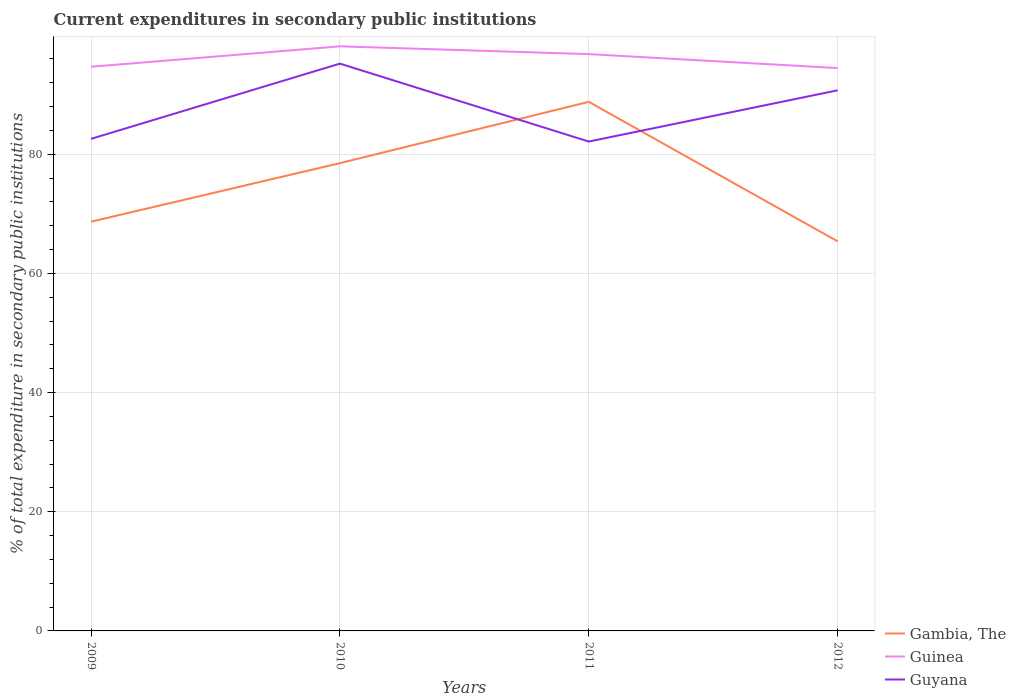How many different coloured lines are there?
Your answer should be very brief. 3. Does the line corresponding to Guyana intersect with the line corresponding to Gambia, The?
Make the answer very short. Yes. Is the number of lines equal to the number of legend labels?
Offer a terse response. Yes. Across all years, what is the maximum current expenditures in secondary public institutions in Guyana?
Ensure brevity in your answer.  82.14. In which year was the current expenditures in secondary public institutions in Guyana maximum?
Offer a terse response. 2011. What is the total current expenditures in secondary public institutions in Guyana in the graph?
Provide a succinct answer. 4.48. What is the difference between the highest and the second highest current expenditures in secondary public institutions in Guinea?
Give a very brief answer. 3.65. Does the graph contain grids?
Your answer should be compact. Yes. How many legend labels are there?
Keep it short and to the point. 3. How are the legend labels stacked?
Give a very brief answer. Vertical. What is the title of the graph?
Ensure brevity in your answer.  Current expenditures in secondary public institutions. Does "Bermuda" appear as one of the legend labels in the graph?
Make the answer very short. No. What is the label or title of the Y-axis?
Your answer should be compact. % of total expenditure in secondary public institutions. What is the % of total expenditure in secondary public institutions in Gambia, The in 2009?
Offer a terse response. 68.69. What is the % of total expenditure in secondary public institutions in Guinea in 2009?
Provide a succinct answer. 94.69. What is the % of total expenditure in secondary public institutions of Guyana in 2009?
Give a very brief answer. 82.59. What is the % of total expenditure in secondary public institutions of Gambia, The in 2010?
Your answer should be compact. 78.52. What is the % of total expenditure in secondary public institutions in Guinea in 2010?
Make the answer very short. 98.12. What is the % of total expenditure in secondary public institutions in Guyana in 2010?
Your answer should be very brief. 95.22. What is the % of total expenditure in secondary public institutions of Gambia, The in 2011?
Provide a short and direct response. 88.81. What is the % of total expenditure in secondary public institutions in Guinea in 2011?
Keep it short and to the point. 96.81. What is the % of total expenditure in secondary public institutions of Guyana in 2011?
Offer a terse response. 82.14. What is the % of total expenditure in secondary public institutions in Gambia, The in 2012?
Your answer should be very brief. 65.39. What is the % of total expenditure in secondary public institutions in Guinea in 2012?
Provide a succinct answer. 94.47. What is the % of total expenditure in secondary public institutions in Guyana in 2012?
Provide a succinct answer. 90.74. Across all years, what is the maximum % of total expenditure in secondary public institutions in Gambia, The?
Give a very brief answer. 88.81. Across all years, what is the maximum % of total expenditure in secondary public institutions in Guinea?
Make the answer very short. 98.12. Across all years, what is the maximum % of total expenditure in secondary public institutions in Guyana?
Give a very brief answer. 95.22. Across all years, what is the minimum % of total expenditure in secondary public institutions of Gambia, The?
Offer a very short reply. 65.39. Across all years, what is the minimum % of total expenditure in secondary public institutions in Guinea?
Keep it short and to the point. 94.47. Across all years, what is the minimum % of total expenditure in secondary public institutions of Guyana?
Your answer should be very brief. 82.14. What is the total % of total expenditure in secondary public institutions of Gambia, The in the graph?
Your response must be concise. 301.4. What is the total % of total expenditure in secondary public institutions in Guinea in the graph?
Your answer should be compact. 384.1. What is the total % of total expenditure in secondary public institutions of Guyana in the graph?
Keep it short and to the point. 350.69. What is the difference between the % of total expenditure in secondary public institutions in Gambia, The in 2009 and that in 2010?
Offer a terse response. -9.83. What is the difference between the % of total expenditure in secondary public institutions of Guinea in 2009 and that in 2010?
Provide a succinct answer. -3.43. What is the difference between the % of total expenditure in secondary public institutions in Guyana in 2009 and that in 2010?
Give a very brief answer. -12.63. What is the difference between the % of total expenditure in secondary public institutions of Gambia, The in 2009 and that in 2011?
Give a very brief answer. -20.12. What is the difference between the % of total expenditure in secondary public institutions in Guinea in 2009 and that in 2011?
Provide a succinct answer. -2.12. What is the difference between the % of total expenditure in secondary public institutions in Guyana in 2009 and that in 2011?
Give a very brief answer. 0.45. What is the difference between the % of total expenditure in secondary public institutions in Gambia, The in 2009 and that in 2012?
Your answer should be very brief. 3.3. What is the difference between the % of total expenditure in secondary public institutions in Guinea in 2009 and that in 2012?
Offer a very short reply. 0.22. What is the difference between the % of total expenditure in secondary public institutions of Guyana in 2009 and that in 2012?
Your answer should be very brief. -8.15. What is the difference between the % of total expenditure in secondary public institutions of Gambia, The in 2010 and that in 2011?
Give a very brief answer. -10.29. What is the difference between the % of total expenditure in secondary public institutions of Guinea in 2010 and that in 2011?
Offer a very short reply. 1.31. What is the difference between the % of total expenditure in secondary public institutions of Guyana in 2010 and that in 2011?
Your answer should be very brief. 13.08. What is the difference between the % of total expenditure in secondary public institutions of Gambia, The in 2010 and that in 2012?
Your answer should be compact. 13.13. What is the difference between the % of total expenditure in secondary public institutions of Guinea in 2010 and that in 2012?
Offer a terse response. 3.65. What is the difference between the % of total expenditure in secondary public institutions in Guyana in 2010 and that in 2012?
Your answer should be compact. 4.48. What is the difference between the % of total expenditure in secondary public institutions of Gambia, The in 2011 and that in 2012?
Your response must be concise. 23.42. What is the difference between the % of total expenditure in secondary public institutions in Guinea in 2011 and that in 2012?
Give a very brief answer. 2.34. What is the difference between the % of total expenditure in secondary public institutions in Guyana in 2011 and that in 2012?
Your response must be concise. -8.6. What is the difference between the % of total expenditure in secondary public institutions in Gambia, The in 2009 and the % of total expenditure in secondary public institutions in Guinea in 2010?
Offer a very short reply. -29.44. What is the difference between the % of total expenditure in secondary public institutions of Gambia, The in 2009 and the % of total expenditure in secondary public institutions of Guyana in 2010?
Your answer should be very brief. -26.53. What is the difference between the % of total expenditure in secondary public institutions of Guinea in 2009 and the % of total expenditure in secondary public institutions of Guyana in 2010?
Offer a very short reply. -0.53. What is the difference between the % of total expenditure in secondary public institutions in Gambia, The in 2009 and the % of total expenditure in secondary public institutions in Guinea in 2011?
Make the answer very short. -28.13. What is the difference between the % of total expenditure in secondary public institutions in Gambia, The in 2009 and the % of total expenditure in secondary public institutions in Guyana in 2011?
Your answer should be very brief. -13.45. What is the difference between the % of total expenditure in secondary public institutions of Guinea in 2009 and the % of total expenditure in secondary public institutions of Guyana in 2011?
Give a very brief answer. 12.55. What is the difference between the % of total expenditure in secondary public institutions in Gambia, The in 2009 and the % of total expenditure in secondary public institutions in Guinea in 2012?
Provide a succinct answer. -25.79. What is the difference between the % of total expenditure in secondary public institutions of Gambia, The in 2009 and the % of total expenditure in secondary public institutions of Guyana in 2012?
Provide a short and direct response. -22.05. What is the difference between the % of total expenditure in secondary public institutions of Guinea in 2009 and the % of total expenditure in secondary public institutions of Guyana in 2012?
Ensure brevity in your answer.  3.95. What is the difference between the % of total expenditure in secondary public institutions in Gambia, The in 2010 and the % of total expenditure in secondary public institutions in Guinea in 2011?
Provide a succinct answer. -18.3. What is the difference between the % of total expenditure in secondary public institutions of Gambia, The in 2010 and the % of total expenditure in secondary public institutions of Guyana in 2011?
Keep it short and to the point. -3.62. What is the difference between the % of total expenditure in secondary public institutions in Guinea in 2010 and the % of total expenditure in secondary public institutions in Guyana in 2011?
Offer a very short reply. 15.98. What is the difference between the % of total expenditure in secondary public institutions in Gambia, The in 2010 and the % of total expenditure in secondary public institutions in Guinea in 2012?
Your answer should be compact. -15.95. What is the difference between the % of total expenditure in secondary public institutions in Gambia, The in 2010 and the % of total expenditure in secondary public institutions in Guyana in 2012?
Ensure brevity in your answer.  -12.22. What is the difference between the % of total expenditure in secondary public institutions of Guinea in 2010 and the % of total expenditure in secondary public institutions of Guyana in 2012?
Ensure brevity in your answer.  7.38. What is the difference between the % of total expenditure in secondary public institutions of Gambia, The in 2011 and the % of total expenditure in secondary public institutions of Guinea in 2012?
Your answer should be very brief. -5.67. What is the difference between the % of total expenditure in secondary public institutions of Gambia, The in 2011 and the % of total expenditure in secondary public institutions of Guyana in 2012?
Your response must be concise. -1.93. What is the difference between the % of total expenditure in secondary public institutions of Guinea in 2011 and the % of total expenditure in secondary public institutions of Guyana in 2012?
Offer a very short reply. 6.07. What is the average % of total expenditure in secondary public institutions in Gambia, The per year?
Your answer should be compact. 75.35. What is the average % of total expenditure in secondary public institutions of Guinea per year?
Make the answer very short. 96.03. What is the average % of total expenditure in secondary public institutions in Guyana per year?
Provide a succinct answer. 87.67. In the year 2009, what is the difference between the % of total expenditure in secondary public institutions of Gambia, The and % of total expenditure in secondary public institutions of Guinea?
Provide a succinct answer. -26.01. In the year 2009, what is the difference between the % of total expenditure in secondary public institutions in Gambia, The and % of total expenditure in secondary public institutions in Guyana?
Give a very brief answer. -13.9. In the year 2009, what is the difference between the % of total expenditure in secondary public institutions of Guinea and % of total expenditure in secondary public institutions of Guyana?
Your response must be concise. 12.1. In the year 2010, what is the difference between the % of total expenditure in secondary public institutions of Gambia, The and % of total expenditure in secondary public institutions of Guinea?
Your response must be concise. -19.6. In the year 2010, what is the difference between the % of total expenditure in secondary public institutions of Gambia, The and % of total expenditure in secondary public institutions of Guyana?
Provide a succinct answer. -16.7. In the year 2010, what is the difference between the % of total expenditure in secondary public institutions of Guinea and % of total expenditure in secondary public institutions of Guyana?
Your answer should be very brief. 2.9. In the year 2011, what is the difference between the % of total expenditure in secondary public institutions of Gambia, The and % of total expenditure in secondary public institutions of Guinea?
Offer a very short reply. -8.01. In the year 2011, what is the difference between the % of total expenditure in secondary public institutions of Gambia, The and % of total expenditure in secondary public institutions of Guyana?
Make the answer very short. 6.67. In the year 2011, what is the difference between the % of total expenditure in secondary public institutions in Guinea and % of total expenditure in secondary public institutions in Guyana?
Offer a terse response. 14.67. In the year 2012, what is the difference between the % of total expenditure in secondary public institutions in Gambia, The and % of total expenditure in secondary public institutions in Guinea?
Offer a terse response. -29.09. In the year 2012, what is the difference between the % of total expenditure in secondary public institutions in Gambia, The and % of total expenditure in secondary public institutions in Guyana?
Your answer should be compact. -25.35. In the year 2012, what is the difference between the % of total expenditure in secondary public institutions in Guinea and % of total expenditure in secondary public institutions in Guyana?
Provide a short and direct response. 3.73. What is the ratio of the % of total expenditure in secondary public institutions in Gambia, The in 2009 to that in 2010?
Provide a succinct answer. 0.87. What is the ratio of the % of total expenditure in secondary public institutions of Guinea in 2009 to that in 2010?
Your answer should be compact. 0.97. What is the ratio of the % of total expenditure in secondary public institutions in Guyana in 2009 to that in 2010?
Provide a short and direct response. 0.87. What is the ratio of the % of total expenditure in secondary public institutions of Gambia, The in 2009 to that in 2011?
Offer a very short reply. 0.77. What is the ratio of the % of total expenditure in secondary public institutions in Guinea in 2009 to that in 2011?
Offer a very short reply. 0.98. What is the ratio of the % of total expenditure in secondary public institutions of Guyana in 2009 to that in 2011?
Your response must be concise. 1.01. What is the ratio of the % of total expenditure in secondary public institutions of Gambia, The in 2009 to that in 2012?
Your response must be concise. 1.05. What is the ratio of the % of total expenditure in secondary public institutions of Guinea in 2009 to that in 2012?
Your answer should be compact. 1. What is the ratio of the % of total expenditure in secondary public institutions in Guyana in 2009 to that in 2012?
Provide a short and direct response. 0.91. What is the ratio of the % of total expenditure in secondary public institutions in Gambia, The in 2010 to that in 2011?
Your response must be concise. 0.88. What is the ratio of the % of total expenditure in secondary public institutions of Guinea in 2010 to that in 2011?
Offer a terse response. 1.01. What is the ratio of the % of total expenditure in secondary public institutions in Guyana in 2010 to that in 2011?
Ensure brevity in your answer.  1.16. What is the ratio of the % of total expenditure in secondary public institutions of Gambia, The in 2010 to that in 2012?
Your answer should be compact. 1.2. What is the ratio of the % of total expenditure in secondary public institutions in Guinea in 2010 to that in 2012?
Your answer should be very brief. 1.04. What is the ratio of the % of total expenditure in secondary public institutions in Guyana in 2010 to that in 2012?
Offer a terse response. 1.05. What is the ratio of the % of total expenditure in secondary public institutions in Gambia, The in 2011 to that in 2012?
Your answer should be compact. 1.36. What is the ratio of the % of total expenditure in secondary public institutions in Guinea in 2011 to that in 2012?
Keep it short and to the point. 1.02. What is the ratio of the % of total expenditure in secondary public institutions in Guyana in 2011 to that in 2012?
Your answer should be very brief. 0.91. What is the difference between the highest and the second highest % of total expenditure in secondary public institutions in Gambia, The?
Your answer should be very brief. 10.29. What is the difference between the highest and the second highest % of total expenditure in secondary public institutions of Guinea?
Ensure brevity in your answer.  1.31. What is the difference between the highest and the second highest % of total expenditure in secondary public institutions of Guyana?
Provide a succinct answer. 4.48. What is the difference between the highest and the lowest % of total expenditure in secondary public institutions in Gambia, The?
Make the answer very short. 23.42. What is the difference between the highest and the lowest % of total expenditure in secondary public institutions of Guinea?
Your answer should be very brief. 3.65. What is the difference between the highest and the lowest % of total expenditure in secondary public institutions of Guyana?
Your answer should be very brief. 13.08. 